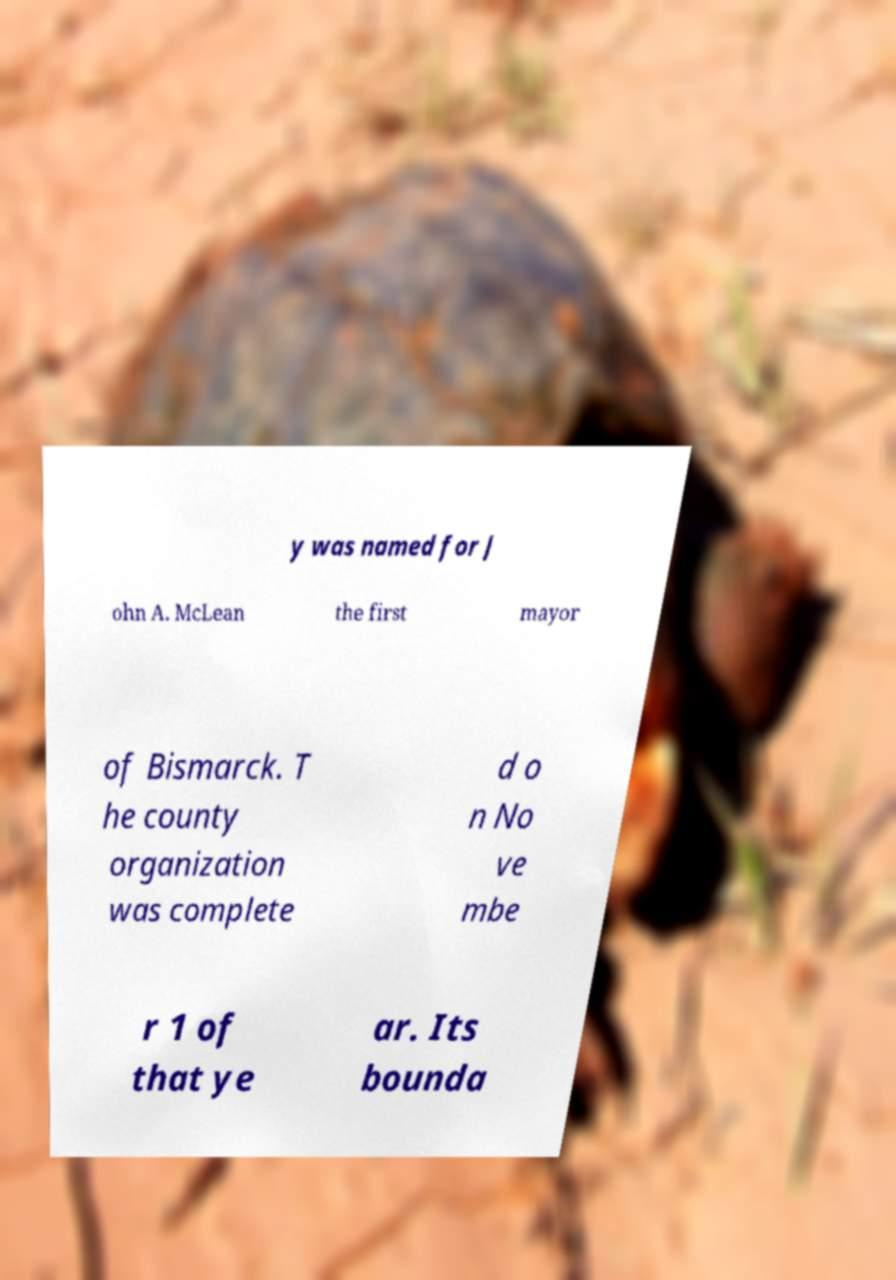Can you accurately transcribe the text from the provided image for me? y was named for J ohn A. McLean the first mayor of Bismarck. T he county organization was complete d o n No ve mbe r 1 of that ye ar. Its bounda 